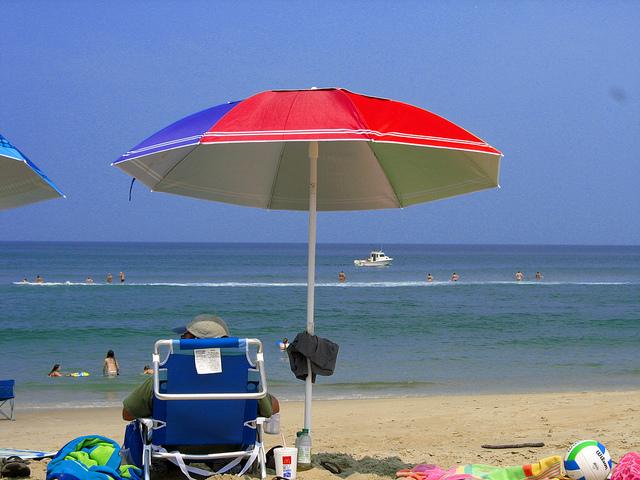What time of day is it?
Keep it brief. Afternoon. Does the man under the umbrella own the boat he is watching?
Short answer required. No. What color is the water?
Answer briefly. Blue. What fast food joint is the white, red and blue cup from?
Write a very short answer. Mcdonald's. How many boats are in this picture?
Short answer required. 1. 